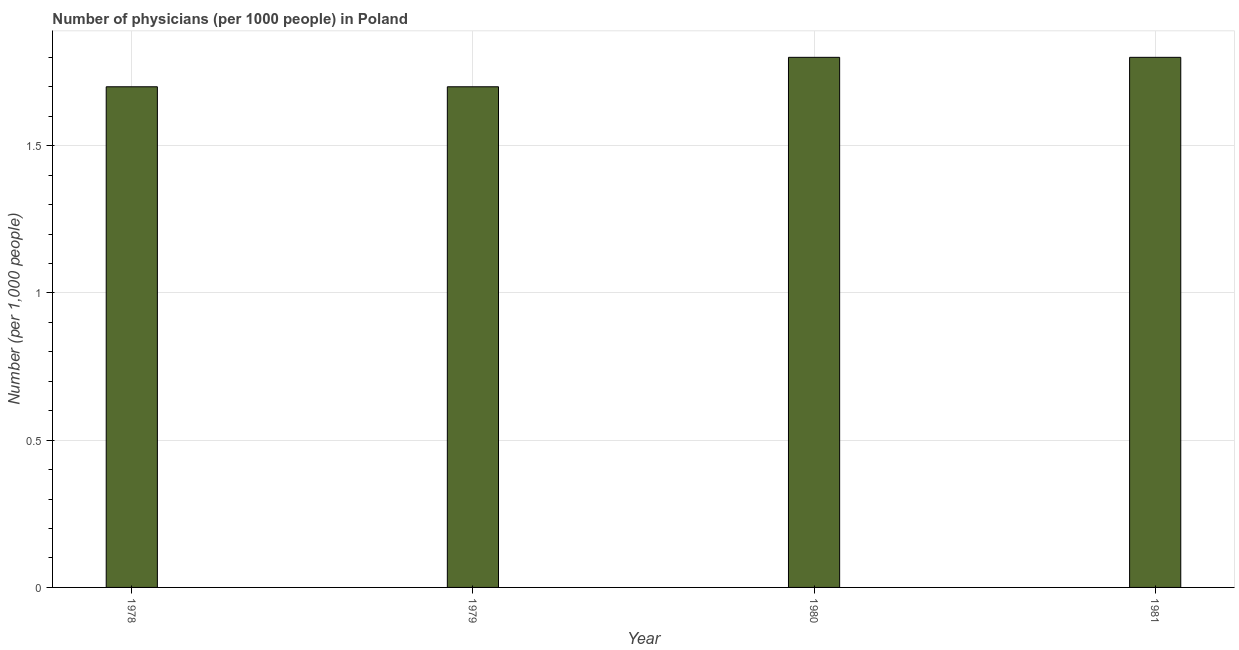Does the graph contain grids?
Your response must be concise. Yes. What is the title of the graph?
Give a very brief answer. Number of physicians (per 1000 people) in Poland. What is the label or title of the X-axis?
Make the answer very short. Year. What is the label or title of the Y-axis?
Provide a short and direct response. Number (per 1,0 people). Across all years, what is the minimum number of physicians?
Provide a short and direct response. 1.7. In which year was the number of physicians minimum?
Ensure brevity in your answer.  1978. What is the difference between the number of physicians in 1979 and 1981?
Ensure brevity in your answer.  -0.1. What is the average number of physicians per year?
Offer a terse response. 1.75. What is the median number of physicians?
Your answer should be compact. 1.75. In how many years, is the number of physicians greater than 0.5 ?
Give a very brief answer. 4. What is the ratio of the number of physicians in 1979 to that in 1980?
Your answer should be very brief. 0.94. Is the difference between the number of physicians in 1978 and 1980 greater than the difference between any two years?
Provide a short and direct response. Yes. Is the sum of the number of physicians in 1978 and 1981 greater than the maximum number of physicians across all years?
Ensure brevity in your answer.  Yes. In how many years, is the number of physicians greater than the average number of physicians taken over all years?
Your answer should be very brief. 2. How many bars are there?
Your answer should be compact. 4. Are all the bars in the graph horizontal?
Offer a very short reply. No. How many years are there in the graph?
Offer a very short reply. 4. What is the Number (per 1,000 people) of 1979?
Your response must be concise. 1.7. What is the Number (per 1,000 people) in 1981?
Keep it short and to the point. 1.8. What is the difference between the Number (per 1,000 people) in 1978 and 1981?
Your answer should be very brief. -0.1. What is the difference between the Number (per 1,000 people) in 1979 and 1981?
Offer a very short reply. -0.1. What is the difference between the Number (per 1,000 people) in 1980 and 1981?
Offer a terse response. 0. What is the ratio of the Number (per 1,000 people) in 1978 to that in 1980?
Ensure brevity in your answer.  0.94. What is the ratio of the Number (per 1,000 people) in 1978 to that in 1981?
Offer a very short reply. 0.94. What is the ratio of the Number (per 1,000 people) in 1979 to that in 1980?
Your response must be concise. 0.94. What is the ratio of the Number (per 1,000 people) in 1979 to that in 1981?
Provide a succinct answer. 0.94. 